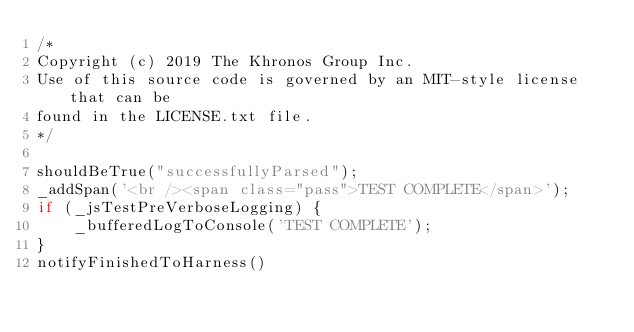<code> <loc_0><loc_0><loc_500><loc_500><_JavaScript_>/*
Copyright (c) 2019 The Khronos Group Inc.
Use of this source code is governed by an MIT-style license that can be
found in the LICENSE.txt file.
*/

shouldBeTrue("successfullyParsed");
_addSpan('<br /><span class="pass">TEST COMPLETE</span>');
if (_jsTestPreVerboseLogging) {
    _bufferedLogToConsole('TEST COMPLETE');
}
notifyFinishedToHarness()
</code> 